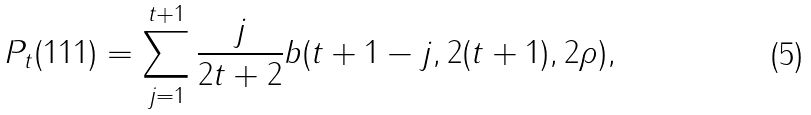Convert formula to latex. <formula><loc_0><loc_0><loc_500><loc_500>P _ { t } ( 1 1 1 ) = \sum _ { j = 1 } ^ { t + 1 } \frac { j } { 2 t + 2 } b ( t + 1 - j , 2 ( t + 1 ) , 2 \rho ) ,</formula> 